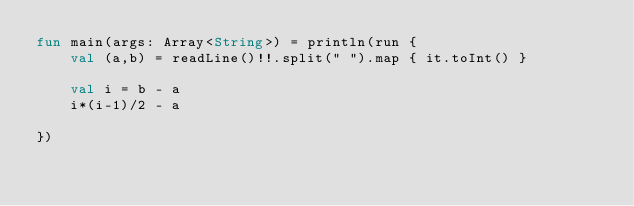Convert code to text. <code><loc_0><loc_0><loc_500><loc_500><_Kotlin_>fun main(args: Array<String>) = println(run {
    val (a,b) = readLine()!!.split(" ").map { it.toInt() }

    val i = b - a
    i*(i-1)/2 - a

})
</code> 